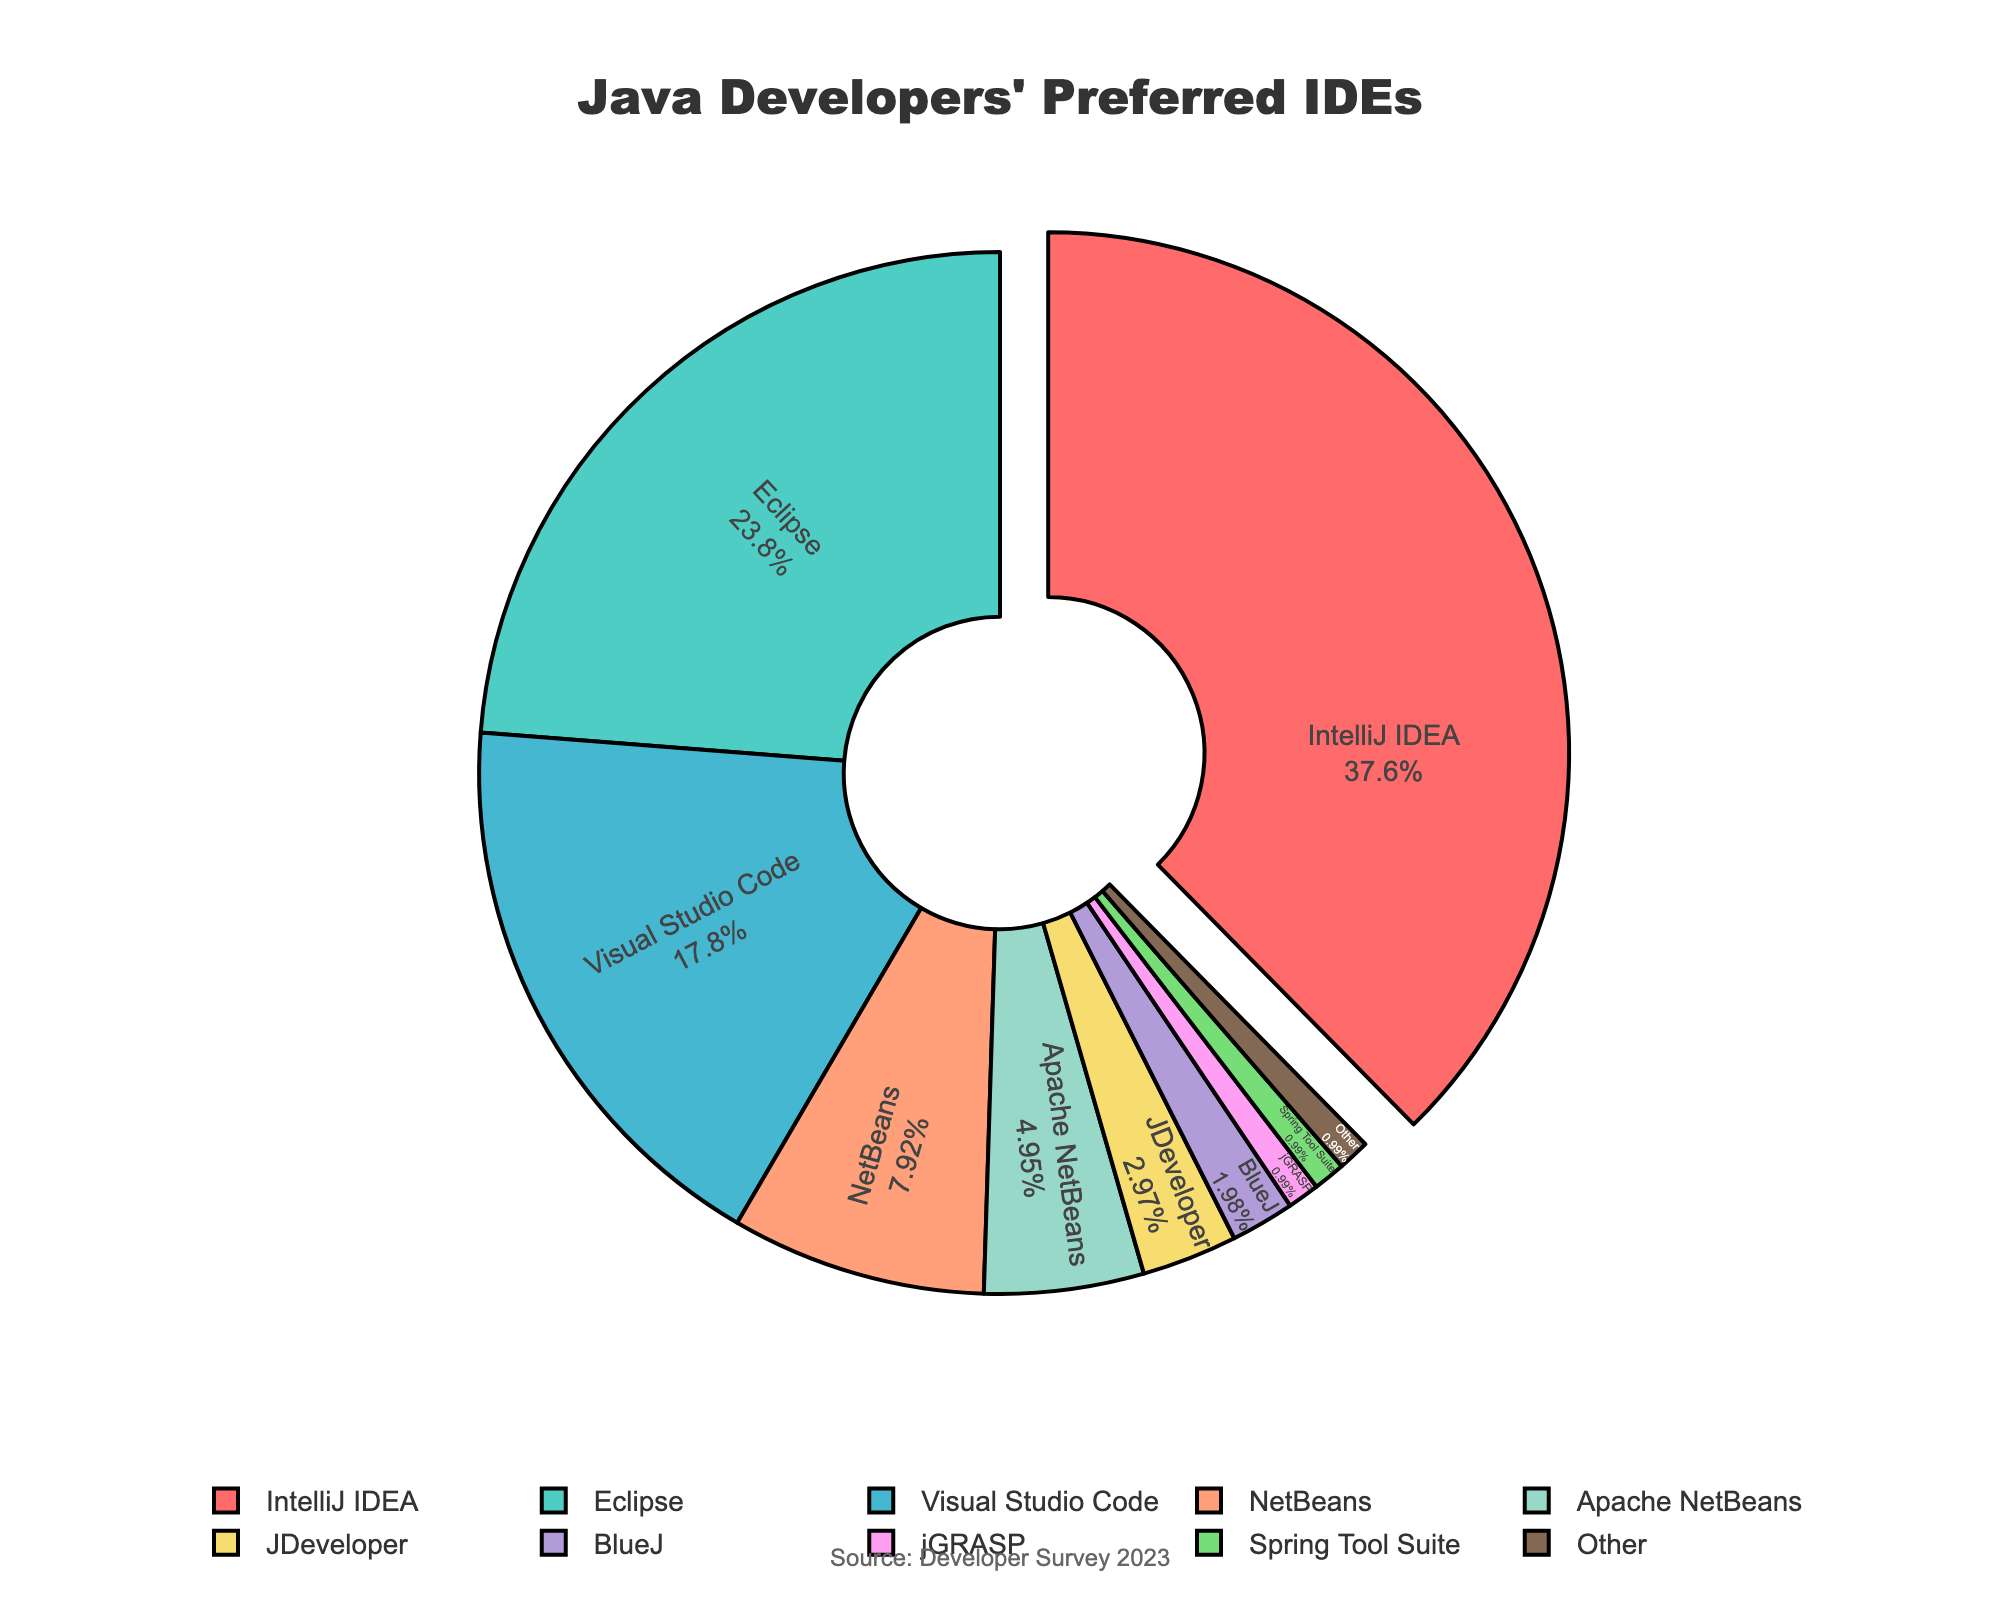What's the largest percentage of Java developers' preferred IDE? The figure shows percentages of Java developers' preferred IDEs, and the largest percentage is shown with a thicker border and is pulled outward from the center. From the figure, the largest segment corresponds to IntelliJ IDEA.
Answer: 38% Which IDEs have a combined preference percentage of more than 50%? By adding the percentages of the top two most preferred IDEs, we get IntelliJ IDEA (38%) and Eclipse (24%). The sum is 38% + 24% = 62%, which is more than 50%.
Answer: IntelliJ IDEA and Eclipse Which IDE is represented by the red segment, and what is its percentage? In the pie chart, each segment has a different color and the segment for IntelliJ IDEA is filled with red. The percentage in the red segment represents its preference.
Answer: IntelliJ IDEA, 38% What's the difference in percentage between the most and least preferred IDEs? The most preferred IDE is IntelliJ IDEA with 38%, and the least preferred IDEs (many with 1%) include jGRASP, Spring Tool Suite, and Other. Thus, the difference is 38% - 1% = 37%.
Answer: 37% How many IDEs have a preference equal to or less than 5%? From the data, the IDEs with preferences equal to or less than 5% are Apache NetBeans (5%), JDeveloper (3%), BlueJ (2%), jGRASP (1%), Spring Tool Suite (1%), and Other (1%). Counting the number of these IDEs gives us 6.
Answer: 6 Which IDEs contribute equally to the least preferred segment? The least preferred segments each represent 1% of the developers and there are three segments with the same percentage: jGRASP, Spring Tool Suite, and Other.
Answer: jGRASP, Spring Tool Suite, and Other What is the combined preference percentage for NetBeans and Apache NetBeans? The figure shows NetBeans with 8% and Apache NetBeans with 5%. Adding these together, we get 8% + 5% = 13%.
Answer: 13% What is the average percentage of preference for the IDEs that have more than a 15% share? The IDEs with more than 15% share are IntelliJ IDEA (38%), Eclipse (24%), and Visual Studio Code (18%). The average is calculated as (38% + 24% + 18%) / 3 = 26.67%.
Answer: 26.67% Which IDE has the third most preferred share, and what is its percentage? The figure orders the IDEs by preference percentage. The third most preferred IDE is Visual Studio Code with 18%.
Answer: Visual Studio Code, 18% What is the visual position of the segment for JDeveloper in terms of color and orientation? In the pie chart, JDeveloper is represented by a segment and colored with a consistent color scheme. By locating the segment specifically assigned to 3%, its color and position can be deduced by its particular placement among others.
Answer: JDeveloper, yellow coloration, right side of the pie 